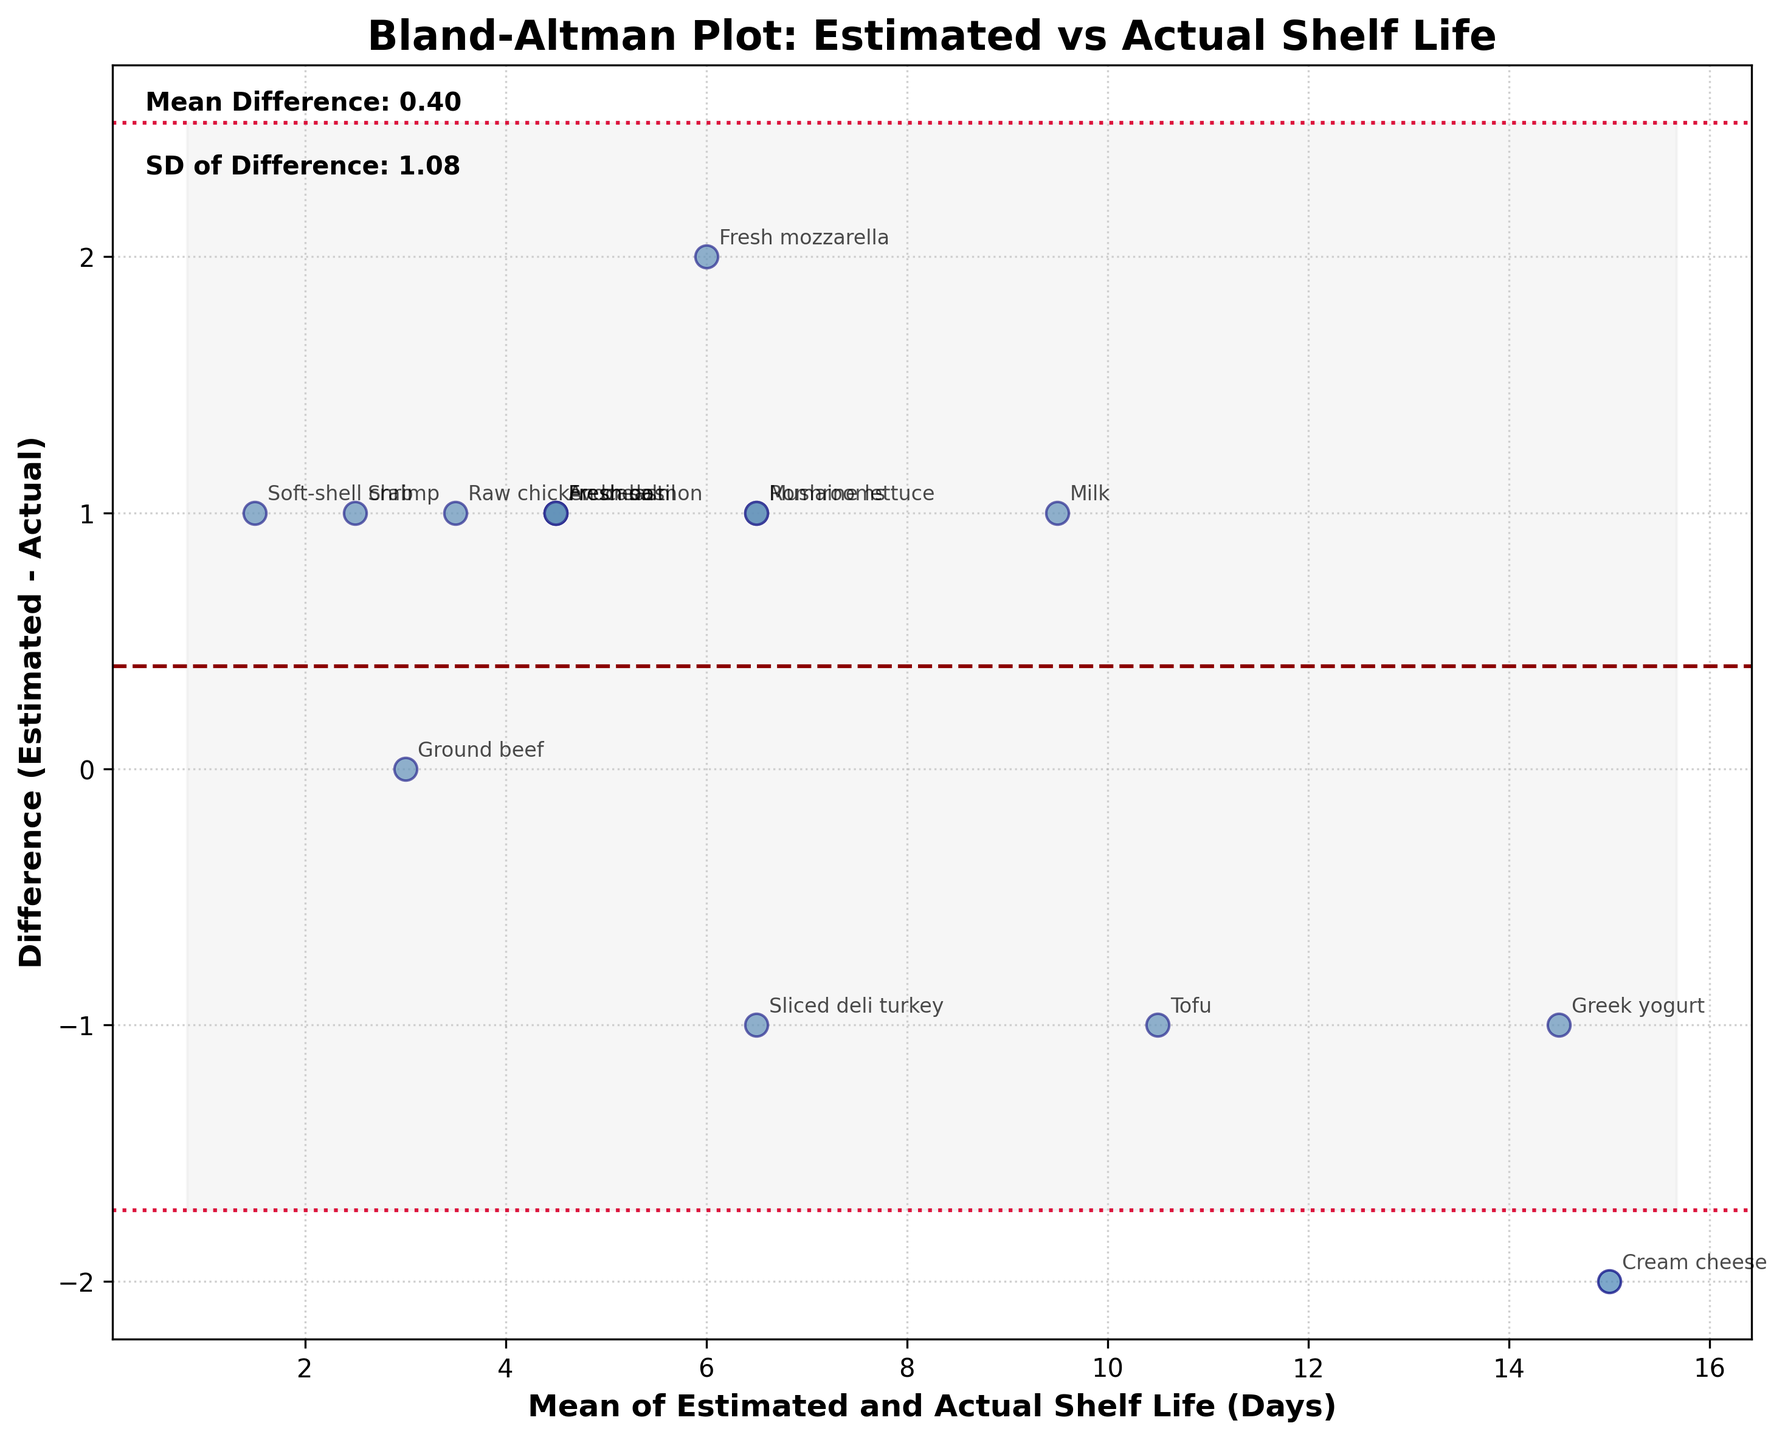what is the title of the plot? The title is prominently displayed at the top of the figure in bold text. It provides an overview of what the plot represents.
Answer: Bland-Altman Plot: Estimated vs Actual Shelf Life how many data points are plotted in the figure? Each ingredient contributes one data point, and individual points are scattered across the plot. Each point represents the difference between estimated and actual shelf life versus their mean.
Answer: 15 what are the axes labels in the plot? The axes labels are located at the bottom and left sides of the plot. They describe what each axis represents. The x-axis describes the mean of the estimated and actual shelf life, and the y-axis describes the difference (estimated - actual) shelf life.
Answer: Mean of Estimated and Actual Shelf Life (Days), Difference (Estimated - Actual) how is the mean difference indicated on the plot? The mean difference is shown as a horizontal dashed line (in dark red) running through the plot. This line represents the average difference between estimated and actual shelf life.
Answer: A dark red dashed line what does the shaded area represent in the figure? The shaded area represents the 95% limits of agreement, which are calculated as the mean difference plus or minus 1.96 times the standard deviation of the differences. This typically indicates where most data points are expected to fall.
Answer: 95% limits of agreement which ingredient has the largest positive difference between estimated and actual shelf life? To determine this, look for the data point plotted at the highest position on the y-axis. This represents the ingredient with the greatest positive difference.
Answer: Cream cheese which ingredient has a perfect agreement between estimated and actual shelf life? A perfect agreement occurs where the difference is zero. Look for the data point lying on the y=0 line.
Answer: Ground beef what is the mean value of the differences plotted? The plot features a text annotation that displays the mean difference. This value is calculated as the average difference between estimated and actual shelf life for all ingredients.
Answer: -0.20 how do the estimated shelf life and actual shelf life compare for sliced deli turkey? Locate the data point corresponding to sliced deli turkey; then check its position on the y-axis to find the difference. A negative difference indicates that the actual shelf life is greater.
Answer: Actual shelf life is greater what are the standard deviation of the differences and the range of 95% limits of agreement? The plot includes text annotations detailing the standard deviation of the differences. The 95% limits of agreement range can be computed using the mean difference and standard deviation values presented in the plot.
Answer: SD: 1.25, Range: -2.65 to 2.25 